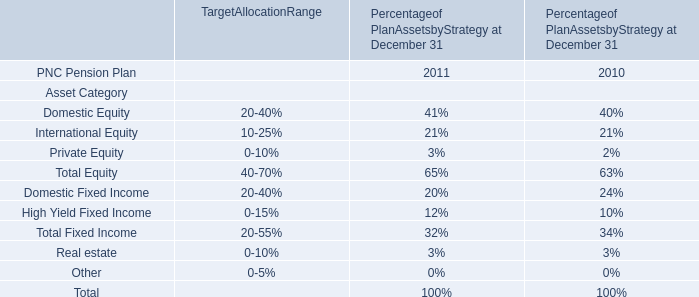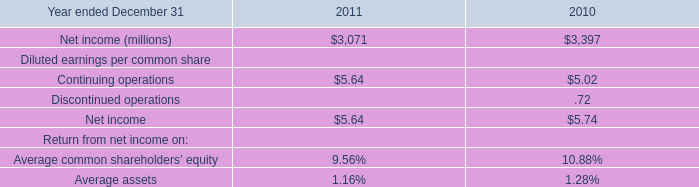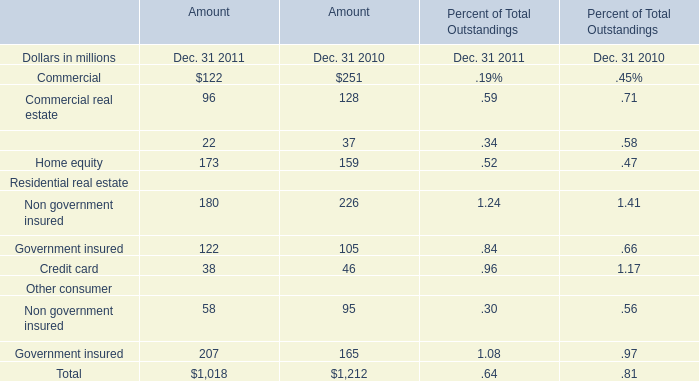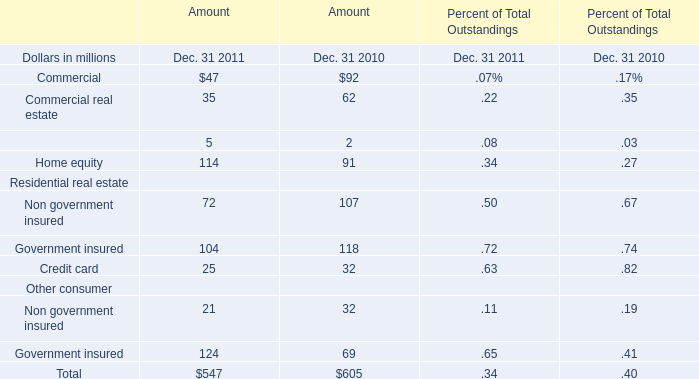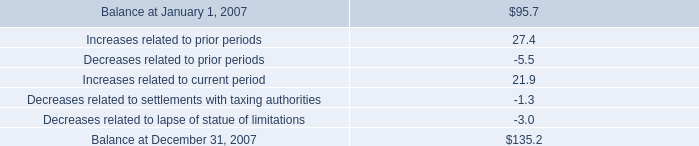What is the growing rate of Government insured for Residential real estate in the year with the most Home equity? (in %) 
Computations: ((122 - 105) / 105)
Answer: 0.1619. 